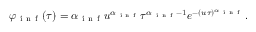Convert formula to latex. <formula><loc_0><loc_0><loc_500><loc_500>\varphi _ { i n f } ( \tau ) = \alpha _ { i n f } u ^ { \alpha _ { i n f } } \tau ^ { \alpha _ { i n f } - 1 } e ^ { - ( u \tau ) ^ { \alpha _ { i n f } } } .</formula> 